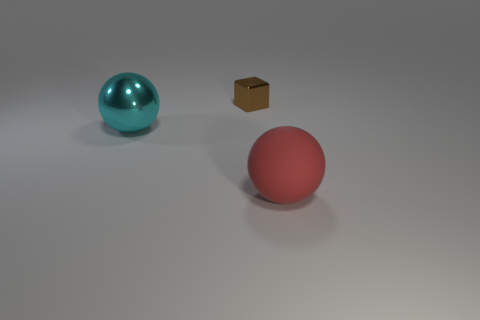Subtract all cyan balls. Subtract all purple cylinders. How many balls are left? 1 Add 2 small brown metallic objects. How many objects exist? 5 Subtract all spheres. How many objects are left? 1 Subtract 0 blue cubes. How many objects are left? 3 Subtract all small brown things. Subtract all red rubber balls. How many objects are left? 1 Add 1 brown metal blocks. How many brown metal blocks are left? 2 Add 2 small yellow matte cylinders. How many small yellow matte cylinders exist? 2 